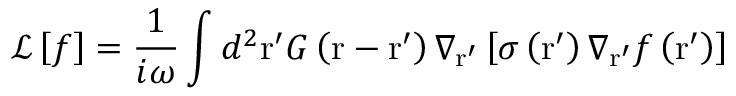<formula> <loc_0><loc_0><loc_500><loc_500>\mathcal { L } \left [ f \right ] = \frac { 1 } { i \omega } \int { { { d } ^ { 2 } } { r } ^ { \prime } G \left ( r - { r } ^ { \prime } \right ) { { \nabla } _ { { { r } ^ { \prime } } } } \left [ \sigma \left ( { { r } ^ { \prime } } \right ) { { \nabla } _ { { { r } ^ { \prime } } } } f \left ( { { r } ^ { \prime } } \right ) \right ] }</formula> 